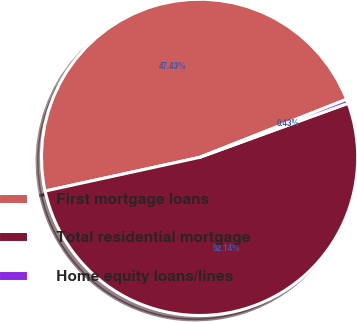Convert chart. <chart><loc_0><loc_0><loc_500><loc_500><pie_chart><fcel>First mortgage loans<fcel>Total residential mortgage<fcel>Home equity loans/lines<nl><fcel>47.43%<fcel>52.14%<fcel>0.43%<nl></chart> 